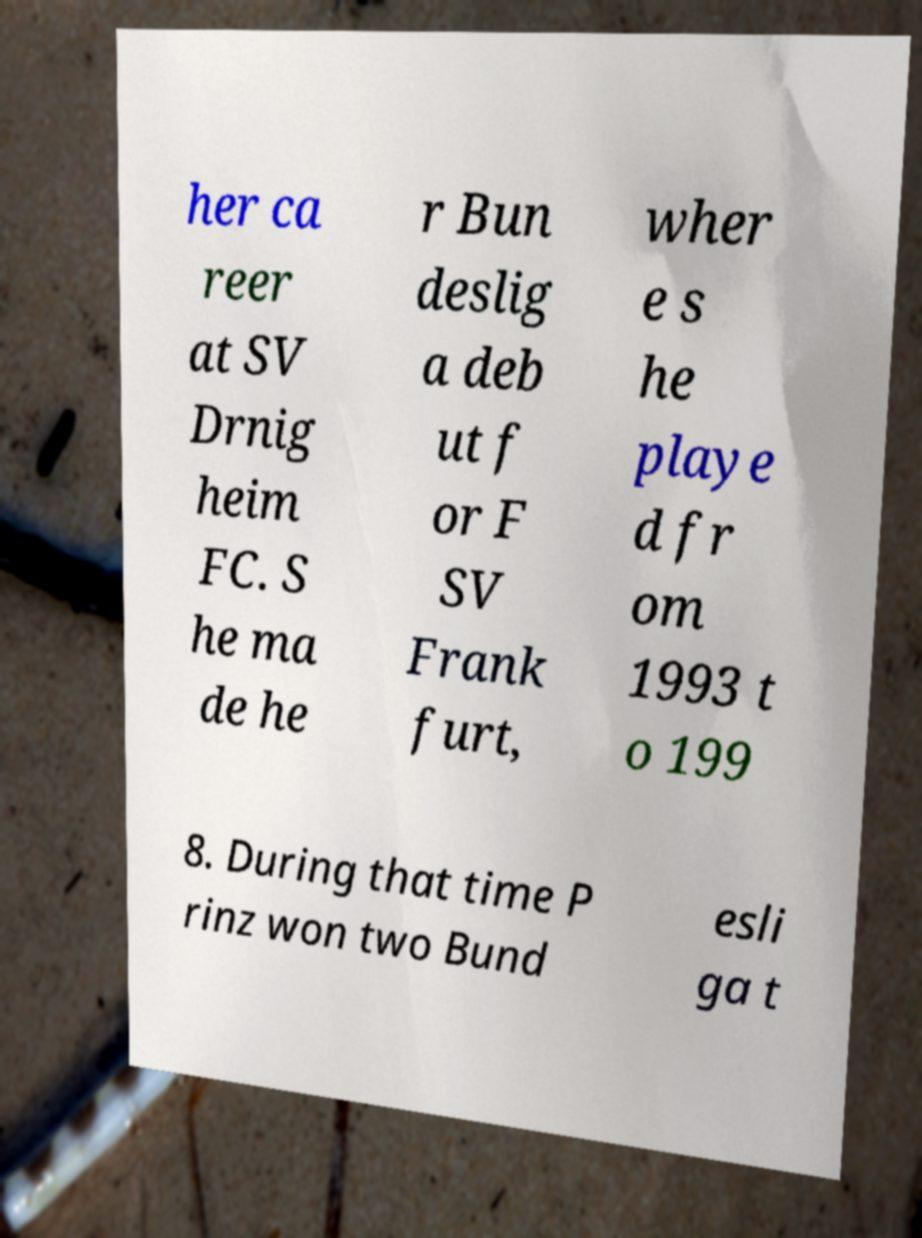Please identify and transcribe the text found in this image. her ca reer at SV Drnig heim FC. S he ma de he r Bun deslig a deb ut f or F SV Frank furt, wher e s he playe d fr om 1993 t o 199 8. During that time P rinz won two Bund esli ga t 